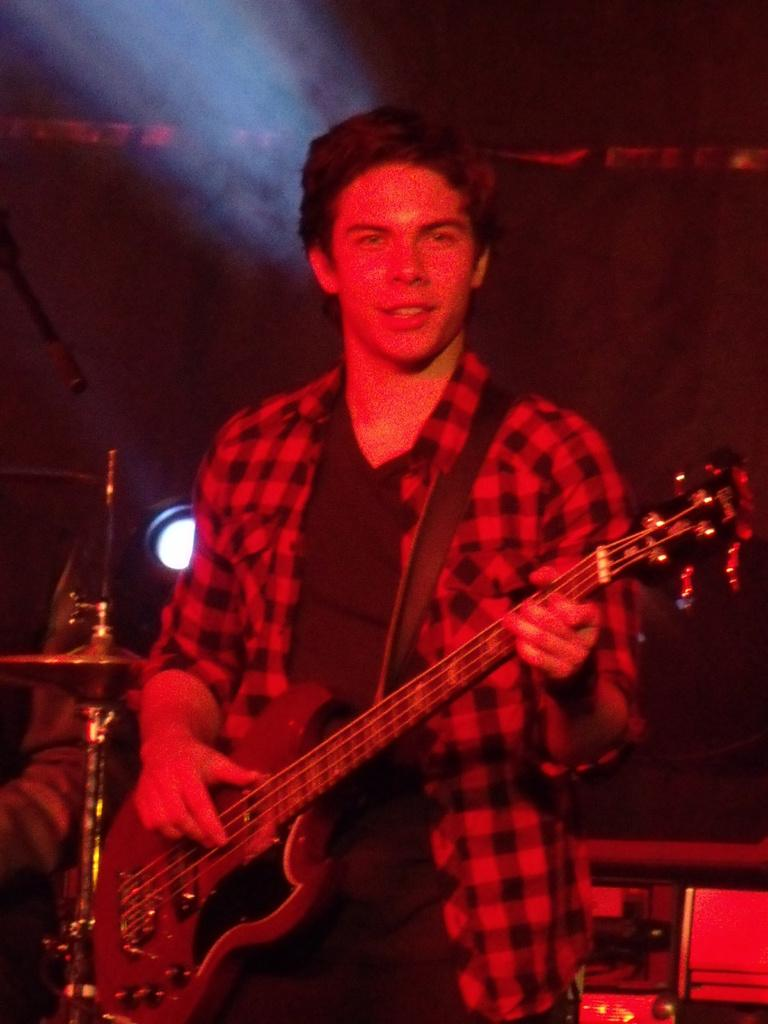What is the main subject of the image? There is a man in the image. What is the man holding in the image? The man is holding a guitar. Can you describe the background of the image? There is a light visible in the background of the image. How does the man stop the cough in the image? There is no cough or indication of a cough in the image. 